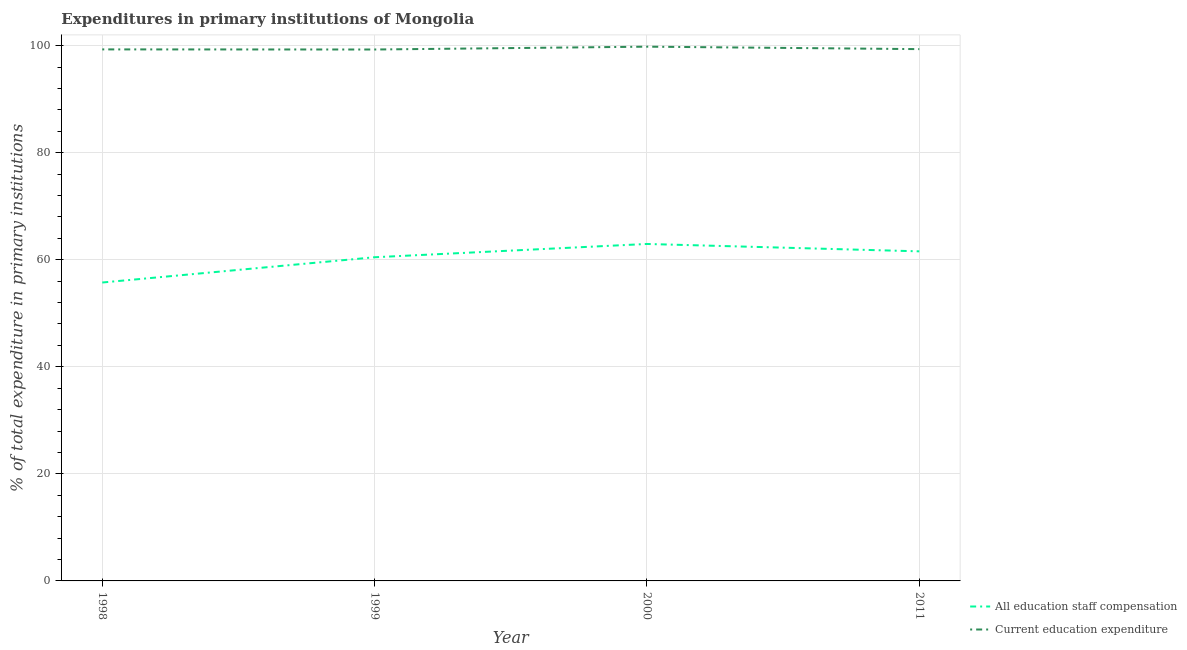How many different coloured lines are there?
Make the answer very short. 2. Is the number of lines equal to the number of legend labels?
Your answer should be very brief. Yes. What is the expenditure in staff compensation in 1998?
Offer a very short reply. 55.74. Across all years, what is the maximum expenditure in staff compensation?
Keep it short and to the point. 62.94. Across all years, what is the minimum expenditure in education?
Your answer should be very brief. 99.27. In which year was the expenditure in education maximum?
Provide a short and direct response. 2000. In which year was the expenditure in education minimum?
Your answer should be very brief. 1999. What is the total expenditure in education in the graph?
Your answer should be compact. 397.7. What is the difference between the expenditure in education in 1999 and that in 2000?
Provide a succinct answer. -0.53. What is the difference between the expenditure in staff compensation in 1998 and the expenditure in education in 2000?
Ensure brevity in your answer.  -44.06. What is the average expenditure in education per year?
Your response must be concise. 99.42. In the year 1998, what is the difference between the expenditure in education and expenditure in staff compensation?
Your answer should be compact. 43.55. In how many years, is the expenditure in education greater than 80 %?
Offer a very short reply. 4. What is the ratio of the expenditure in education in 2000 to that in 2011?
Offer a terse response. 1. Is the expenditure in staff compensation in 1998 less than that in 2011?
Ensure brevity in your answer.  Yes. What is the difference between the highest and the second highest expenditure in staff compensation?
Offer a very short reply. 1.38. What is the difference between the highest and the lowest expenditure in staff compensation?
Make the answer very short. 7.2. Does the expenditure in staff compensation monotonically increase over the years?
Ensure brevity in your answer.  No. Is the expenditure in staff compensation strictly less than the expenditure in education over the years?
Make the answer very short. Yes. How many lines are there?
Keep it short and to the point. 2. How many years are there in the graph?
Your answer should be very brief. 4. What is the difference between two consecutive major ticks on the Y-axis?
Give a very brief answer. 20. Are the values on the major ticks of Y-axis written in scientific E-notation?
Your response must be concise. No. Does the graph contain any zero values?
Your answer should be compact. No. Does the graph contain grids?
Your answer should be very brief. Yes. How are the legend labels stacked?
Offer a terse response. Vertical. What is the title of the graph?
Your answer should be very brief. Expenditures in primary institutions of Mongolia. Does "Time to import" appear as one of the legend labels in the graph?
Your response must be concise. No. What is the label or title of the X-axis?
Keep it short and to the point. Year. What is the label or title of the Y-axis?
Keep it short and to the point. % of total expenditure in primary institutions. What is the % of total expenditure in primary institutions in All education staff compensation in 1998?
Your answer should be very brief. 55.74. What is the % of total expenditure in primary institutions in Current education expenditure in 1998?
Provide a short and direct response. 99.29. What is the % of total expenditure in primary institutions in All education staff compensation in 1999?
Ensure brevity in your answer.  60.46. What is the % of total expenditure in primary institutions in Current education expenditure in 1999?
Make the answer very short. 99.27. What is the % of total expenditure in primary institutions in All education staff compensation in 2000?
Your answer should be very brief. 62.94. What is the % of total expenditure in primary institutions in Current education expenditure in 2000?
Your response must be concise. 99.8. What is the % of total expenditure in primary institutions of All education staff compensation in 2011?
Your answer should be compact. 61.57. What is the % of total expenditure in primary institutions of Current education expenditure in 2011?
Give a very brief answer. 99.34. Across all years, what is the maximum % of total expenditure in primary institutions in All education staff compensation?
Offer a very short reply. 62.94. Across all years, what is the maximum % of total expenditure in primary institutions of Current education expenditure?
Provide a succinct answer. 99.8. Across all years, what is the minimum % of total expenditure in primary institutions of All education staff compensation?
Your response must be concise. 55.74. Across all years, what is the minimum % of total expenditure in primary institutions of Current education expenditure?
Your response must be concise. 99.27. What is the total % of total expenditure in primary institutions of All education staff compensation in the graph?
Keep it short and to the point. 240.72. What is the total % of total expenditure in primary institutions of Current education expenditure in the graph?
Provide a short and direct response. 397.7. What is the difference between the % of total expenditure in primary institutions in All education staff compensation in 1998 and that in 1999?
Your response must be concise. -4.72. What is the difference between the % of total expenditure in primary institutions in Current education expenditure in 1998 and that in 1999?
Provide a succinct answer. 0.02. What is the difference between the % of total expenditure in primary institutions of All education staff compensation in 1998 and that in 2000?
Make the answer very short. -7.2. What is the difference between the % of total expenditure in primary institutions of Current education expenditure in 1998 and that in 2000?
Provide a short and direct response. -0.51. What is the difference between the % of total expenditure in primary institutions in All education staff compensation in 1998 and that in 2011?
Keep it short and to the point. -5.82. What is the difference between the % of total expenditure in primary institutions in Current education expenditure in 1998 and that in 2011?
Give a very brief answer. -0.05. What is the difference between the % of total expenditure in primary institutions in All education staff compensation in 1999 and that in 2000?
Your response must be concise. -2.48. What is the difference between the % of total expenditure in primary institutions in Current education expenditure in 1999 and that in 2000?
Your answer should be compact. -0.53. What is the difference between the % of total expenditure in primary institutions in All education staff compensation in 1999 and that in 2011?
Your answer should be very brief. -1.1. What is the difference between the % of total expenditure in primary institutions in Current education expenditure in 1999 and that in 2011?
Your answer should be very brief. -0.07. What is the difference between the % of total expenditure in primary institutions in All education staff compensation in 2000 and that in 2011?
Offer a terse response. 1.38. What is the difference between the % of total expenditure in primary institutions in Current education expenditure in 2000 and that in 2011?
Make the answer very short. 0.46. What is the difference between the % of total expenditure in primary institutions of All education staff compensation in 1998 and the % of total expenditure in primary institutions of Current education expenditure in 1999?
Offer a terse response. -43.52. What is the difference between the % of total expenditure in primary institutions in All education staff compensation in 1998 and the % of total expenditure in primary institutions in Current education expenditure in 2000?
Your response must be concise. -44.06. What is the difference between the % of total expenditure in primary institutions in All education staff compensation in 1998 and the % of total expenditure in primary institutions in Current education expenditure in 2011?
Your answer should be very brief. -43.6. What is the difference between the % of total expenditure in primary institutions in All education staff compensation in 1999 and the % of total expenditure in primary institutions in Current education expenditure in 2000?
Your response must be concise. -39.34. What is the difference between the % of total expenditure in primary institutions in All education staff compensation in 1999 and the % of total expenditure in primary institutions in Current education expenditure in 2011?
Provide a succinct answer. -38.88. What is the difference between the % of total expenditure in primary institutions in All education staff compensation in 2000 and the % of total expenditure in primary institutions in Current education expenditure in 2011?
Your response must be concise. -36.4. What is the average % of total expenditure in primary institutions in All education staff compensation per year?
Ensure brevity in your answer.  60.18. What is the average % of total expenditure in primary institutions in Current education expenditure per year?
Offer a terse response. 99.42. In the year 1998, what is the difference between the % of total expenditure in primary institutions of All education staff compensation and % of total expenditure in primary institutions of Current education expenditure?
Your answer should be compact. -43.55. In the year 1999, what is the difference between the % of total expenditure in primary institutions of All education staff compensation and % of total expenditure in primary institutions of Current education expenditure?
Your response must be concise. -38.81. In the year 2000, what is the difference between the % of total expenditure in primary institutions in All education staff compensation and % of total expenditure in primary institutions in Current education expenditure?
Provide a succinct answer. -36.86. In the year 2011, what is the difference between the % of total expenditure in primary institutions in All education staff compensation and % of total expenditure in primary institutions in Current education expenditure?
Provide a succinct answer. -37.77. What is the ratio of the % of total expenditure in primary institutions in All education staff compensation in 1998 to that in 1999?
Provide a short and direct response. 0.92. What is the ratio of the % of total expenditure in primary institutions of Current education expenditure in 1998 to that in 1999?
Your response must be concise. 1. What is the ratio of the % of total expenditure in primary institutions in All education staff compensation in 1998 to that in 2000?
Make the answer very short. 0.89. What is the ratio of the % of total expenditure in primary institutions in All education staff compensation in 1998 to that in 2011?
Provide a short and direct response. 0.91. What is the ratio of the % of total expenditure in primary institutions of Current education expenditure in 1998 to that in 2011?
Provide a succinct answer. 1. What is the ratio of the % of total expenditure in primary institutions of All education staff compensation in 1999 to that in 2000?
Your answer should be compact. 0.96. What is the ratio of the % of total expenditure in primary institutions of All education staff compensation in 1999 to that in 2011?
Provide a succinct answer. 0.98. What is the ratio of the % of total expenditure in primary institutions in Current education expenditure in 1999 to that in 2011?
Offer a terse response. 1. What is the ratio of the % of total expenditure in primary institutions in All education staff compensation in 2000 to that in 2011?
Provide a succinct answer. 1.02. What is the difference between the highest and the second highest % of total expenditure in primary institutions in All education staff compensation?
Give a very brief answer. 1.38. What is the difference between the highest and the second highest % of total expenditure in primary institutions in Current education expenditure?
Your answer should be very brief. 0.46. What is the difference between the highest and the lowest % of total expenditure in primary institutions in All education staff compensation?
Provide a succinct answer. 7.2. What is the difference between the highest and the lowest % of total expenditure in primary institutions in Current education expenditure?
Ensure brevity in your answer.  0.53. 